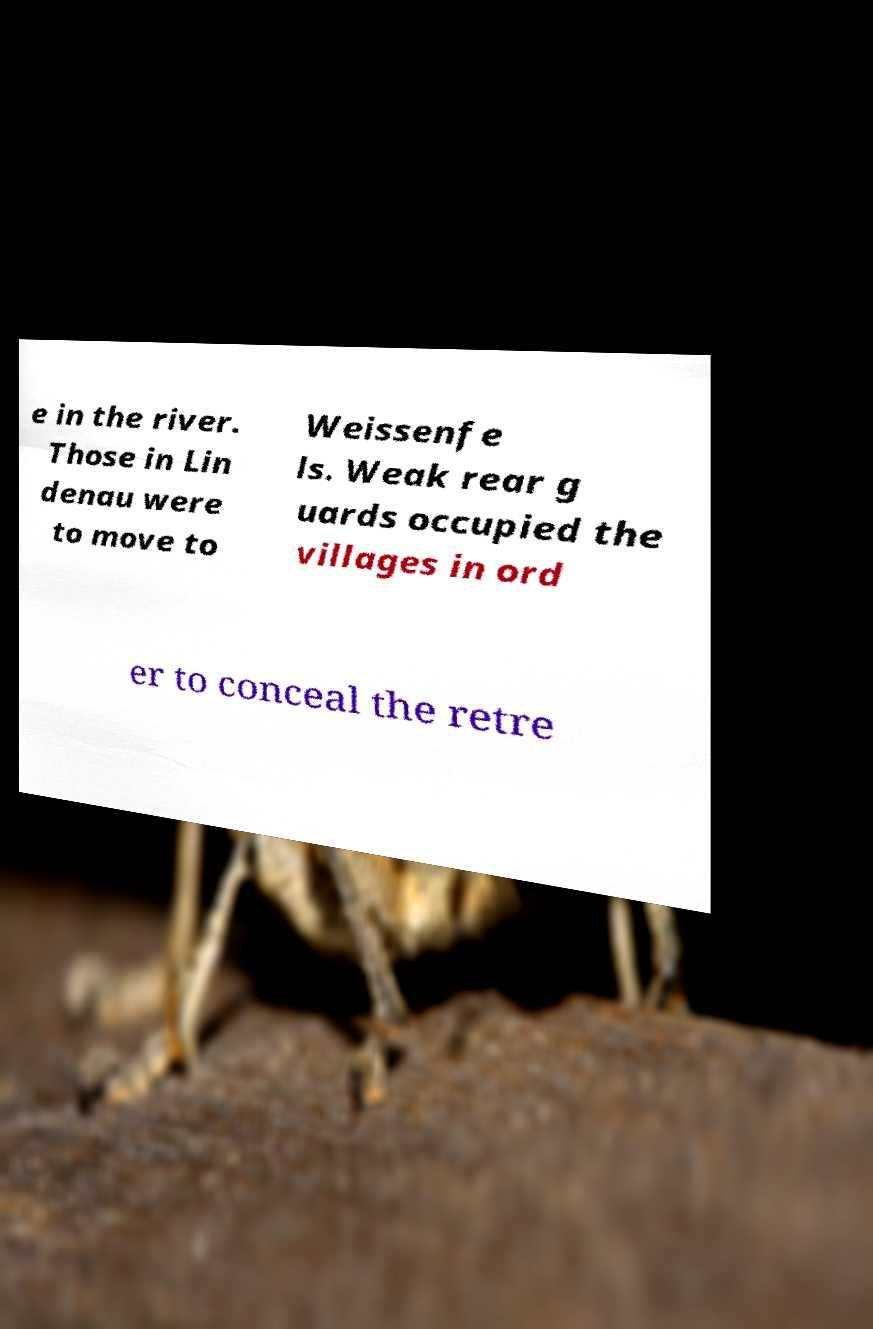Please identify and transcribe the text found in this image. e in the river. Those in Lin denau were to move to Weissenfe ls. Weak rear g uards occupied the villages in ord er to conceal the retre 